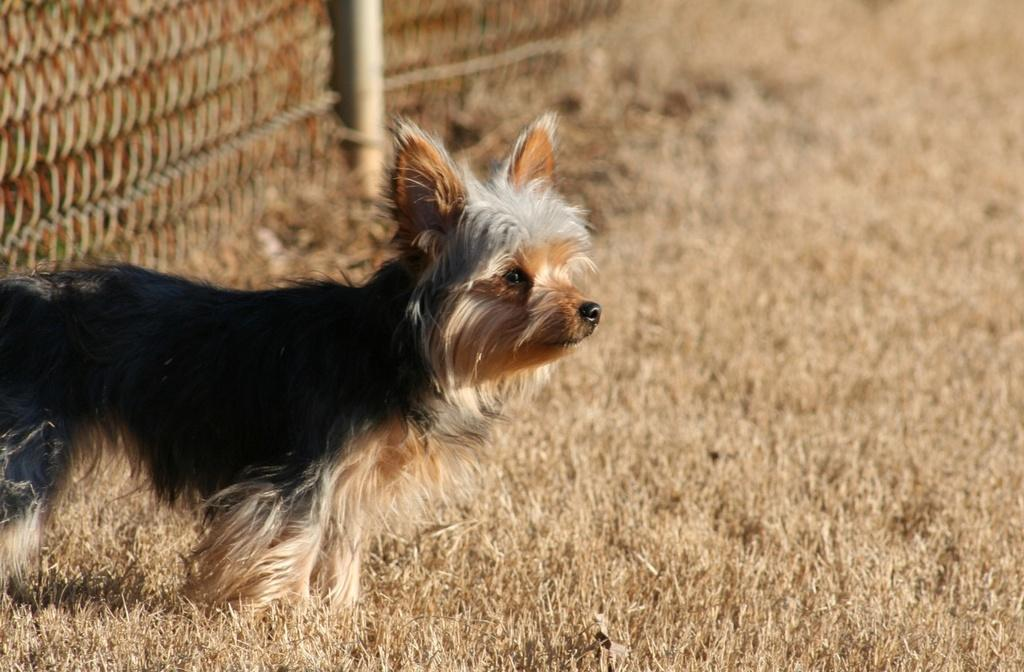What type of vegetation can be seen in the image? There is grass in the image. What animal is present in the image? There is a dog in the image. What can be seen towards the top of the image? There is fencing towards the top of the image. What type of butter is being used to maintain the fencing in the image? There is no butter present in the image, and the fencing does not require any maintenance. 